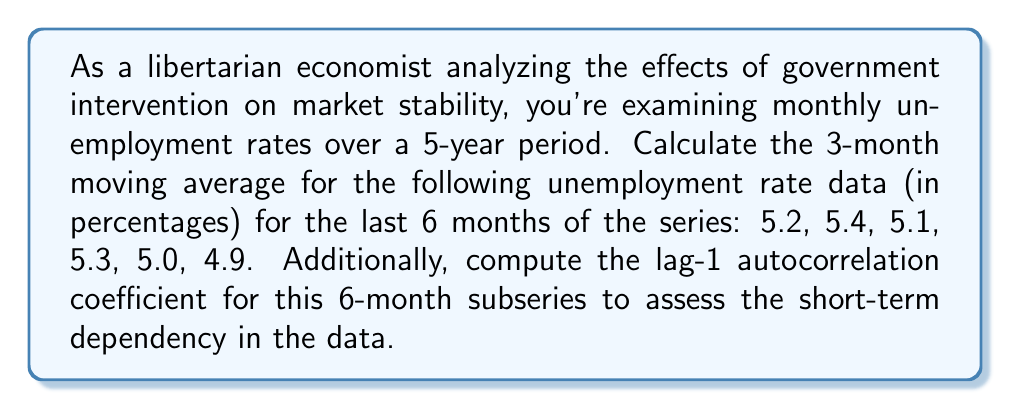Could you help me with this problem? To solve this problem, we'll break it down into two parts: calculating the 3-month moving average and computing the lag-1 autocorrelation coefficient.

1. Calculating the 3-month moving average:
The 3-month moving average is calculated by taking the average of three consecutive months' data points. For a series $x_1, x_2, ..., x_n$, the 3-month moving average at time $t$ is given by:

$$ MA_t = \frac{x_{t-2} + x_{t-1} + x_t}{3} $$

For our data:
$MA_3 = \frac{5.2 + 5.4 + 5.1}{3} = 5.23$
$MA_4 = \frac{5.4 + 5.1 + 5.3}{3} = 5.27$
$MA_5 = \frac{5.1 + 5.3 + 5.0}{3} = 5.13$
$MA_6 = \frac{5.3 + 5.0 + 4.9}{3} = 5.07$

2. Computing the lag-1 autocorrelation coefficient:
The lag-1 autocorrelation coefficient measures the correlation between a time series and a one-step lagged version of itself. It's calculated using the formula:

$$ r_1 = \frac{\sum_{t=2}^{n} (x_t - \bar{x})(x_{t-1} - \bar{x})}{\sum_{t=1}^{n} (x_t - \bar{x})^2} $$

Where $\bar{x}$ is the mean of the series.

First, calculate the mean:
$\bar{x} = \frac{5.2 + 5.4 + 5.1 + 5.3 + 5.0 + 4.9}{6} = 5.15$

Now, calculate the numerator and denominator:

Numerator: $(5.4 - 5.15)(5.2 - 5.15) + (5.1 - 5.15)(5.4 - 5.15) + (5.3 - 5.15)(5.1 - 5.15) + (5.0 - 5.15)(5.3 - 5.15) + (4.9 - 5.15)(5.0 - 5.15) = 0.0275$

Denominator: $(5.2 - 5.15)^2 + (5.4 - 5.15)^2 + (5.1 - 5.15)^2 + (5.3 - 5.15)^2 + (5.0 - 5.15)^2 + (4.9 - 5.15)^2 = 0.1475$

Lag-1 autocorrelation coefficient:
$r_1 = \frac{0.0275}{0.1475} = 0.1864$
Answer: The 3-month moving averages are: 5.23, 5.27, 5.13, 5.07.
The lag-1 autocorrelation coefficient is 0.1864. 